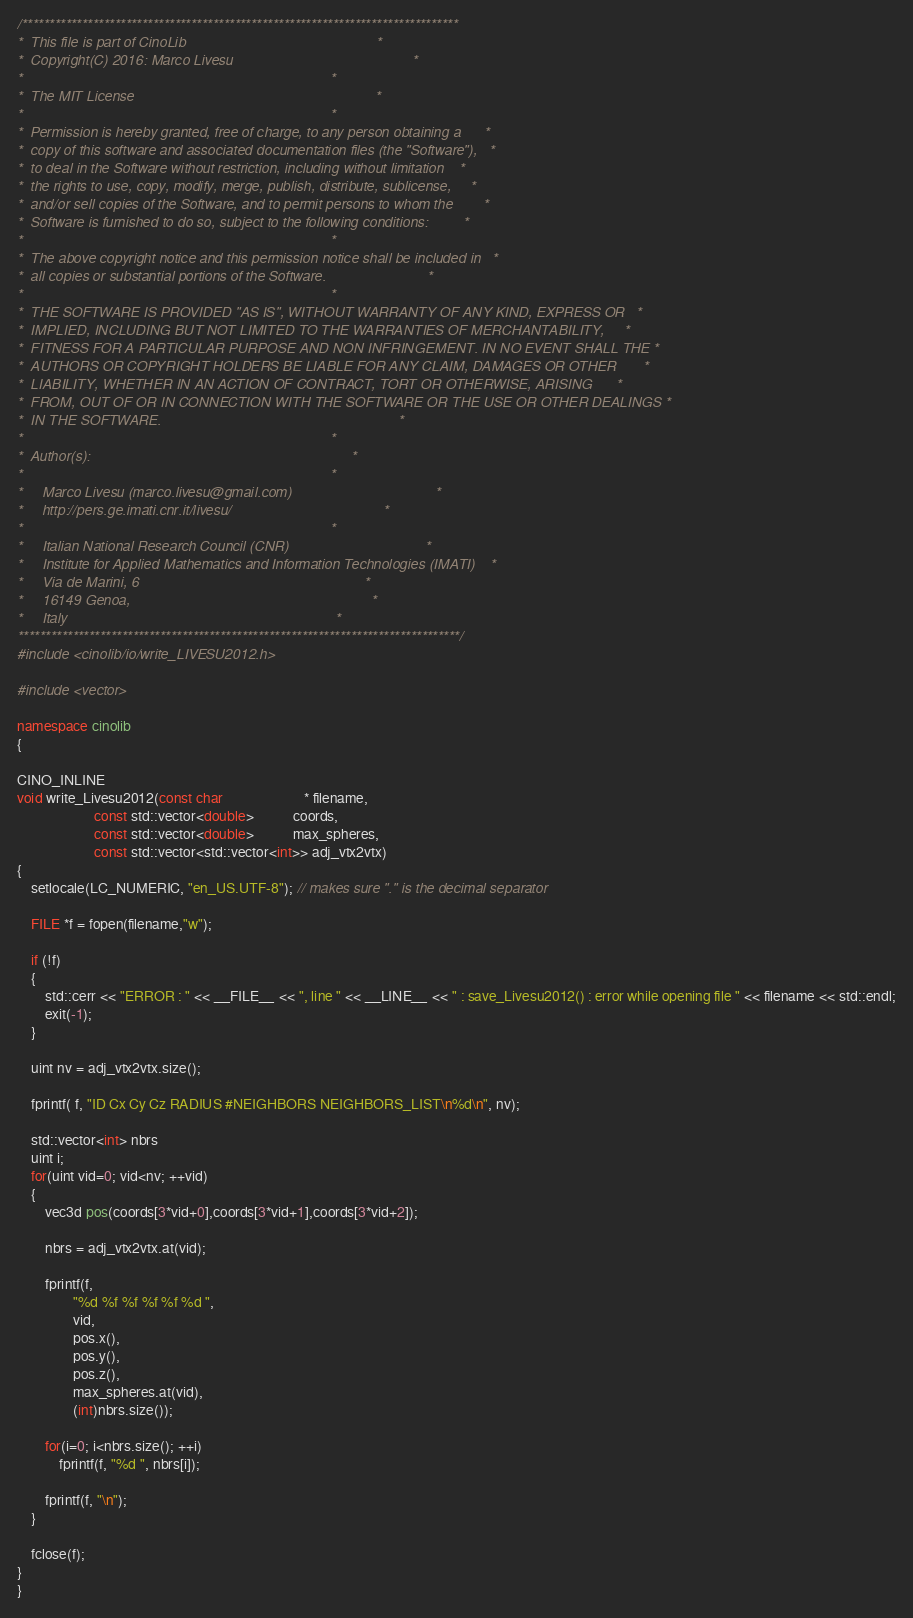Convert code to text. <code><loc_0><loc_0><loc_500><loc_500><_C++_>/********************************************************************************
*  This file is part of CinoLib                                                 *
*  Copyright(C) 2016: Marco Livesu                                              *
*                                                                               *
*  The MIT License                                                              *
*                                                                               *
*  Permission is hereby granted, free of charge, to any person obtaining a      *
*  copy of this software and associated documentation files (the "Software"),   *
*  to deal in the Software without restriction, including without limitation    *
*  the rights to use, copy, modify, merge, publish, distribute, sublicense,     *
*  and/or sell copies of the Software, and to permit persons to whom the        *
*  Software is furnished to do so, subject to the following conditions:         *
*                                                                               *
*  The above copyright notice and this permission notice shall be included in   *
*  all copies or substantial portions of the Software.                          *
*                                                                               *
*  THE SOFTWARE IS PROVIDED "AS IS", WITHOUT WARRANTY OF ANY KIND, EXPRESS OR   *
*  IMPLIED, INCLUDING BUT NOT LIMITED TO THE WARRANTIES OF MERCHANTABILITY,     *
*  FITNESS FOR A PARTICULAR PURPOSE AND NON INFRINGEMENT. IN NO EVENT SHALL THE *
*  AUTHORS OR COPYRIGHT HOLDERS BE LIABLE FOR ANY CLAIM, DAMAGES OR OTHER       *
*  LIABILITY, WHETHER IN AN ACTION OF CONTRACT, TORT OR OTHERWISE, ARISING      *
*  FROM, OUT OF OR IN CONNECTION WITH THE SOFTWARE OR THE USE OR OTHER DEALINGS *
*  IN THE SOFTWARE.                                                             *
*                                                                               *
*  Author(s):                                                                   *
*                                                                               *
*     Marco Livesu (marco.livesu@gmail.com)                                     *
*     http://pers.ge.imati.cnr.it/livesu/                                       *
*                                                                               *
*     Italian National Research Council (CNR)                                   *
*     Institute for Applied Mathematics and Information Technologies (IMATI)    *
*     Via de Marini, 6                                                          *
*     16149 Genoa,                                                              *
*     Italy                                                                     *
*********************************************************************************/
#include <cinolib/io/write_LIVESU2012.h>

#include <vector>

namespace cinolib
{

CINO_INLINE
void write_Livesu2012(const char                       * filename,
                      const std::vector<double>           coords,
                      const std::vector<double>           max_spheres,
                      const std::vector<std::vector<int>> adj_vtx2vtx)
{
    setlocale(LC_NUMERIC, "en_US.UTF-8"); // makes sure "." is the decimal separator

    FILE *f = fopen(filename,"w");

    if (!f)
    {
        std::cerr << "ERROR : " << __FILE__ << ", line " << __LINE__ << " : save_Livesu2012() : error while opening file " << filename << std::endl;
        exit(-1);
    }

    uint nv = adj_vtx2vtx.size();

    fprintf( f, "ID Cx Cy Cz RADIUS #NEIGHBORS NEIGHBORS_LIST\n%d\n", nv);

    std::vector<int> nbrs
    uint i;
    for(uint vid=0; vid<nv; ++vid)
    {
        vec3d pos(coords[3*vid+0],coords[3*vid+1],coords[3*vid+2]);

        nbrs = adj_vtx2vtx.at(vid);

        fprintf(f,
                "%d %f %f %f %f %d ",
                vid,
                pos.x(),
                pos.y(),
                pos.z(),
                max_spheres.at(vid),
                (int)nbrs.size());

        for(i=0; i<nbrs.size(); ++i)
            fprintf(f, "%d ", nbrs[i]);

        fprintf(f, "\n");
    }

    fclose(f);
}
}
</code> 